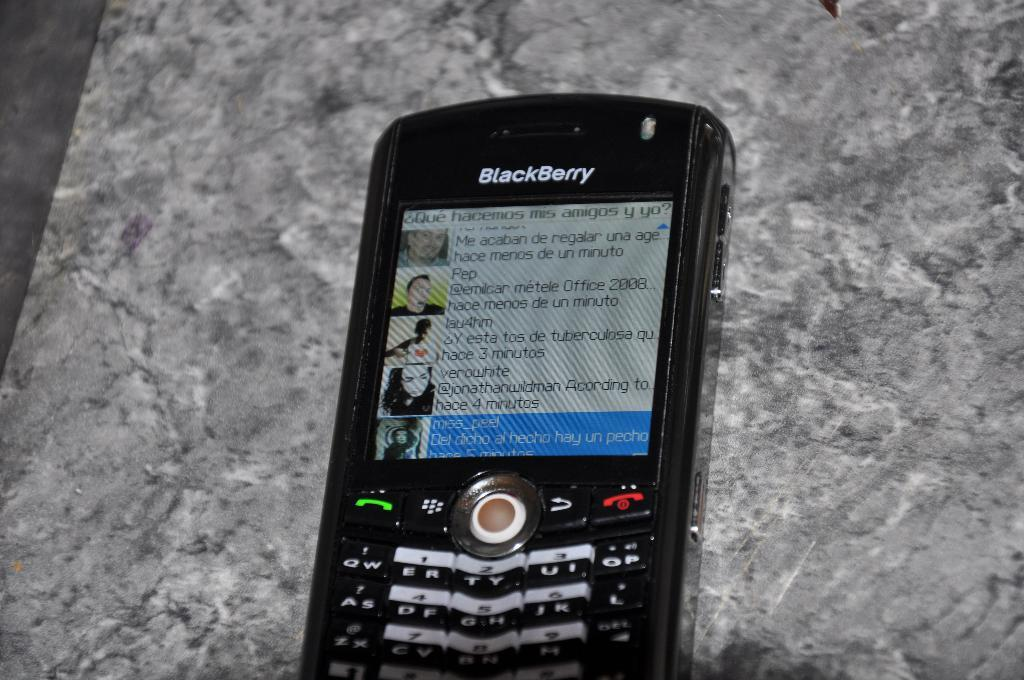What is the color of the phone in the image? The phone in the image is black. Where is the phone located in the image? The phone is on a surface. What can be seen on the screen of the phone? There are photos of people on the phone. Are there any markings or text on the phone? Yes, there is writing on the phone. What is written at the top of the phone? There is a name on the top of the phone. Can you see any clouds in the image? No, there are no clouds present in the image; it features a black phone with photos of people on the screen. Is there a cat visible in the image? No, there is no cat present in the image. 